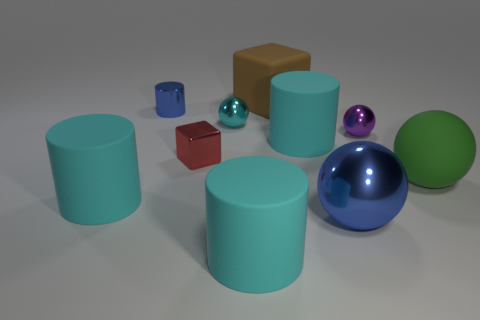Subtract all cyan cylinders. How many were subtracted if there are1cyan cylinders left? 2 Subtract all blue blocks. How many cyan cylinders are left? 3 Subtract 1 balls. How many balls are left? 3 Subtract all spheres. How many objects are left? 6 Add 3 blue rubber balls. How many blue rubber balls exist? 3 Subtract 2 cyan cylinders. How many objects are left? 8 Subtract all tiny green cylinders. Subtract all red metal blocks. How many objects are left? 9 Add 6 small red metal objects. How many small red metal objects are left? 7 